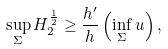Convert formula to latex. <formula><loc_0><loc_0><loc_500><loc_500>\sup _ { \Sigma } H _ { 2 } ^ { \frac { 1 } { 2 } } \geq \frac { h ^ { \prime } } { h } \left ( \inf _ { \Sigma } u \right ) ,</formula> 